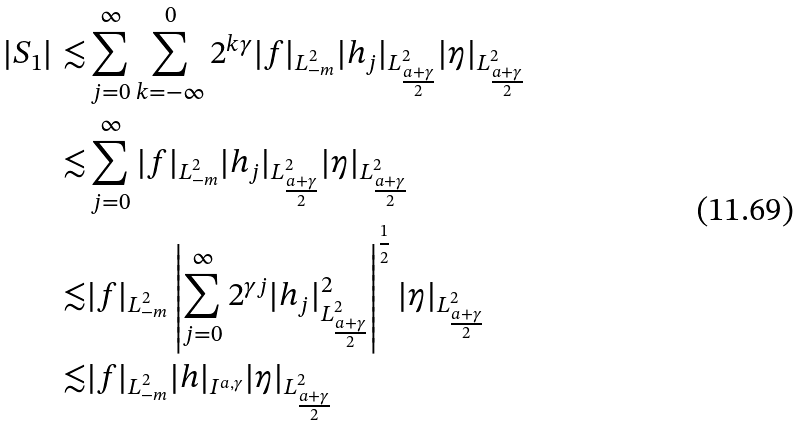<formula> <loc_0><loc_0><loc_500><loc_500>| S _ { 1 } | \lesssim & \sum _ { j = 0 } ^ { \infty } \sum _ { k = - \infty } ^ { 0 } 2 ^ { k \gamma } | f | _ { L ^ { 2 } _ { - m } } | h _ { j } | _ { L ^ { 2 } _ { \frac { a + \gamma } { 2 } } } | \eta | _ { L ^ { 2 } _ { \frac { a + \gamma } { 2 } } } \\ \lesssim & \sum _ { j = 0 } ^ { \infty } | f | _ { L ^ { 2 } _ { - m } } | h _ { j } | _ { L ^ { 2 } _ { \frac { a + \gamma } { 2 } } } | \eta | _ { L ^ { 2 } _ { \frac { a + \gamma } { 2 } } } \\ \lesssim & | f | _ { L ^ { 2 } _ { - m } } \left | \sum _ { j = 0 } ^ { \infty } 2 ^ { \gamma j } | h _ { j } | ^ { 2 } _ { L ^ { 2 } _ { \frac { a + \gamma } { 2 } } } \right | ^ { \frac { 1 } { 2 } } | \eta | _ { L ^ { 2 } _ { \frac { a + \gamma } { 2 } } } \\ \lesssim & | f | _ { L ^ { 2 } _ { - m } } | h | _ { I ^ { a , \gamma } } | \eta | _ { L ^ { 2 } _ { \frac { a + \gamma } { 2 } } }</formula> 